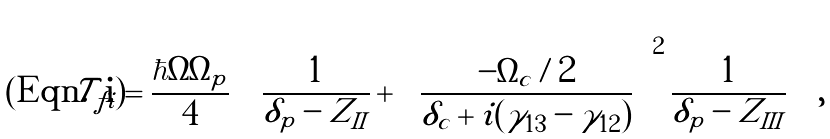Convert formula to latex. <formula><loc_0><loc_0><loc_500><loc_500>\mathcal { T } _ { f i } = \frac { \hbar { \Omega } \Omega _ { p } } { 4 } \left ( \frac { 1 } { \delta _ { p } - Z _ { I I } } + \left [ \frac { - \Omega _ { c } / 2 } { \delta _ { c } + i ( \gamma _ { 1 3 } - \gamma _ { 1 2 } ) } \right ] ^ { 2 } \frac { 1 } { \delta _ { p } - Z _ { I I I } } \right ) ,</formula> 